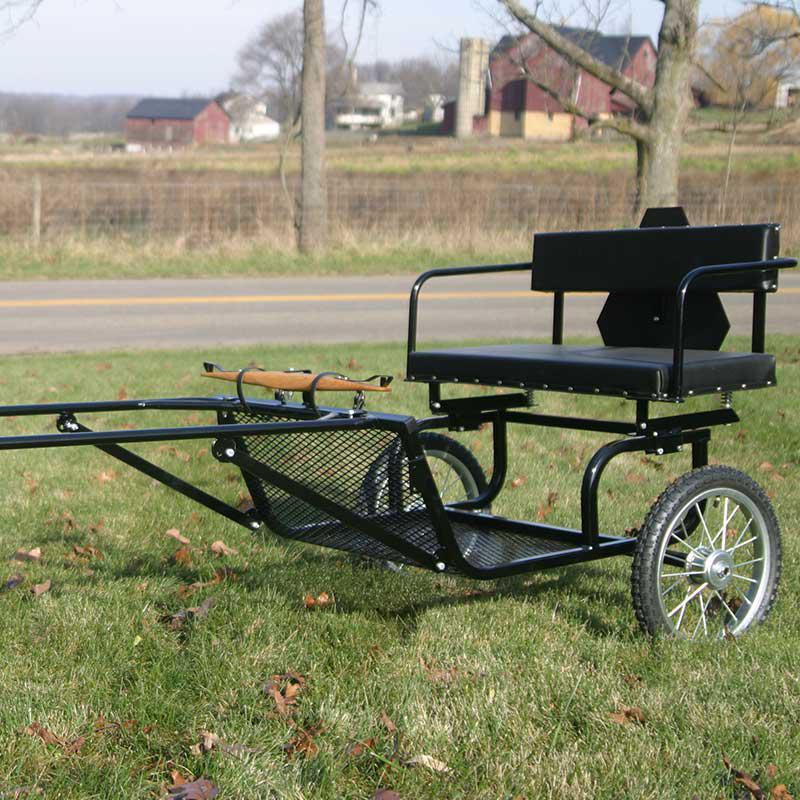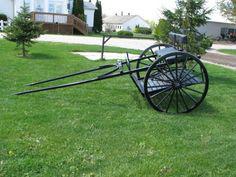The first image is the image on the left, the second image is the image on the right. Evaluate the accuracy of this statement regarding the images: "One of the carriages is red and black.". Is it true? Answer yes or no. No. The first image is the image on the left, the second image is the image on the right. Given the left and right images, does the statement "A two-wheeled black cart is displayed in a side view on grass, with its leads touching the ground." hold true? Answer yes or no. Yes. 